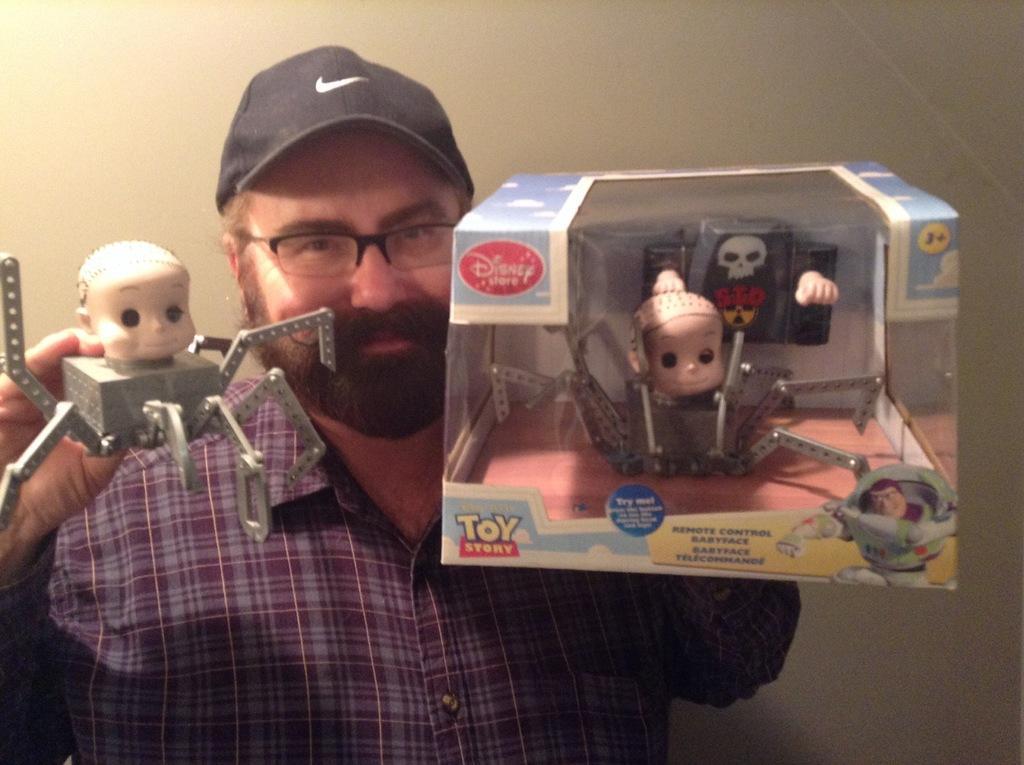Please provide a concise description of this image. In the middle of the image a man is standing and smiling and holding toys. Behind him there is wall. 